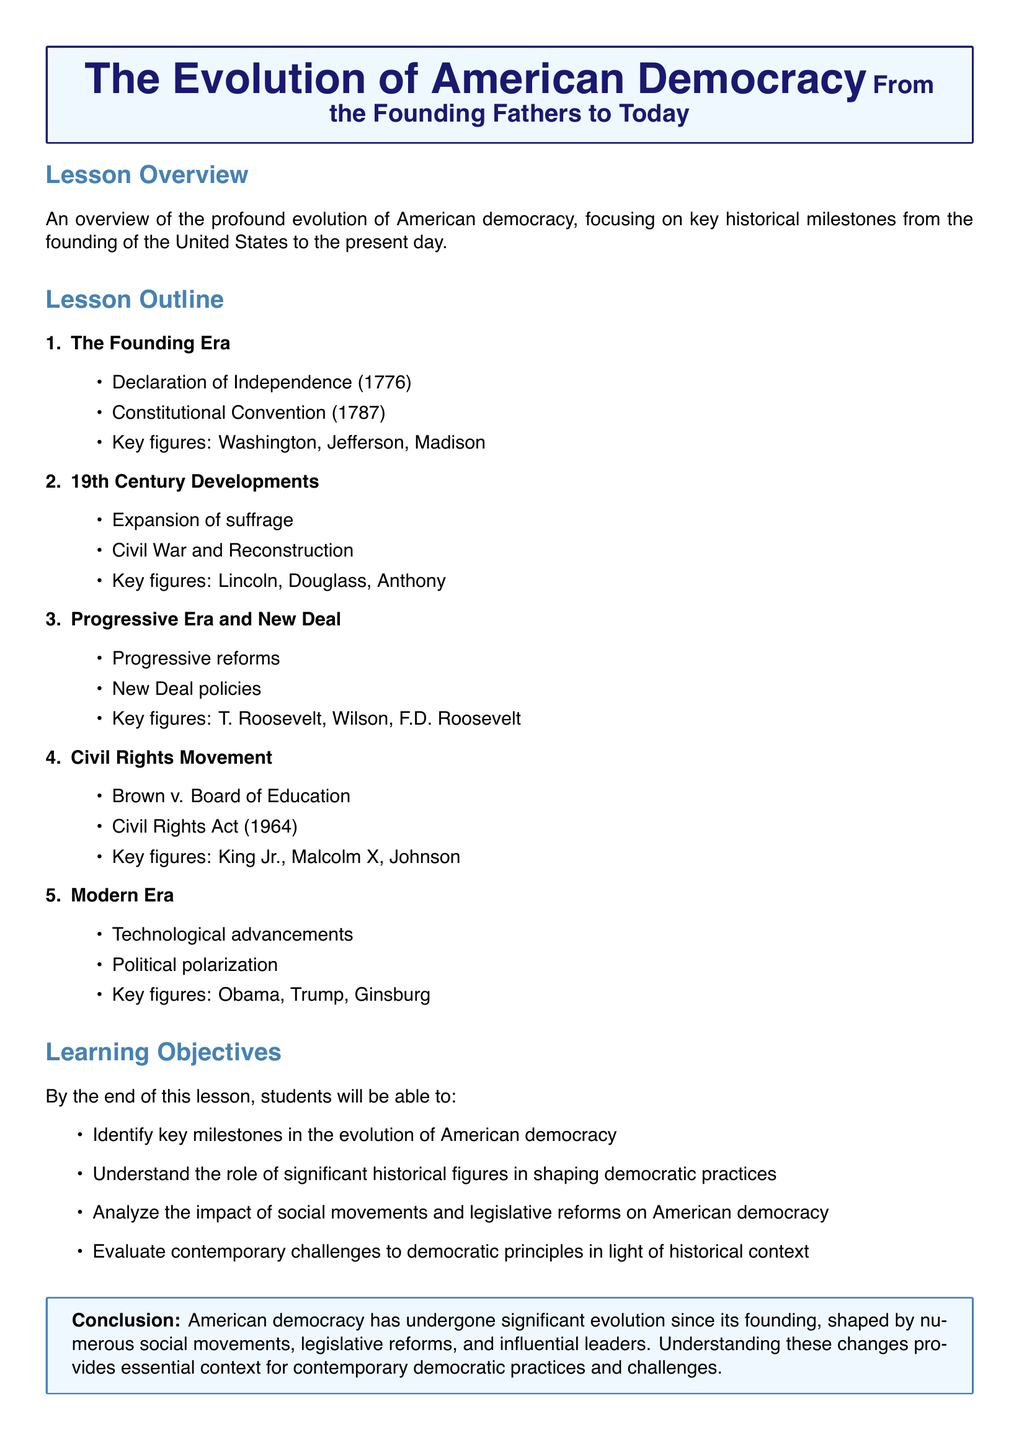What year was the Declaration of Independence adopted? The document states that the Declaration of Independence was adopted in 1776.
Answer: 1776 Who were the key figures during the Founding Era? The document lists Washington, Jefferson, and Madison as key figures during the Founding Era.
Answer: Washington, Jefferson, Madison What major event does the document associate with 19th Century Developments? The document mentions the Civil War and Reconstruction as a significant development in the 19th Century.
Answer: Civil War and Reconstruction Which legislation is highlighted from the Civil Rights Movement? The Civil Rights Act of 1964 is specifically mentioned in the context of the Civil Rights Movement.
Answer: Civil Rights Act (1964) Who is listed as a key figure from the Progressive Era and New Deal? The document identifies T. Roosevelt as one of the key figures from the Progressive Era and New Deal.
Answer: T. Roosevelt What is one of the learning objectives of the lesson? The document states that students will be able to identify key milestones in the evolution of American democracy.
Answer: Identify key milestones What does the document suggest has impacted modern American democracy? Technological advancements are noted as a factor influencing modern American democracy according to the document.
Answer: Technological advancements What significant court case is mentioned in relation to the Civil Rights Movement? The document refers to Brown v. Board of Education as an important case in the Civil Rights Movement.
Answer: Brown v. Board of Education What does the conclusion of the lesson emphasize? The conclusion emphasizes that American democracy has undergone significant evolution shaped by various factors.
Answer: Significant evolution 